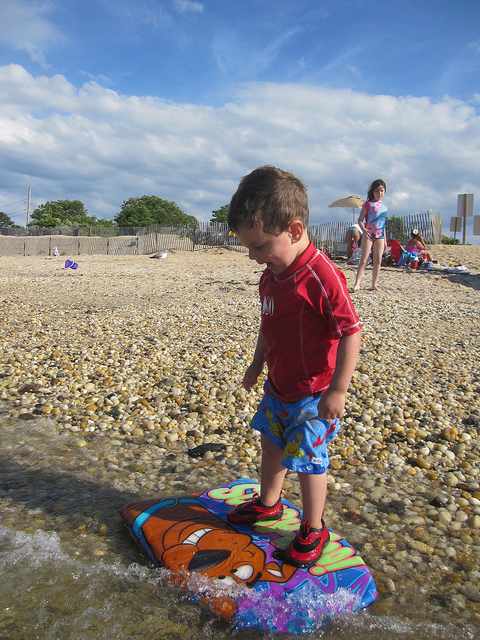<image>What is on his left wrist? I am not sure what is on his left wrist. It can be nothing, wristband or watch imprint. What is on his left wrist? I am not sure what is on his left wrist. It can be nothing or a wristband. 